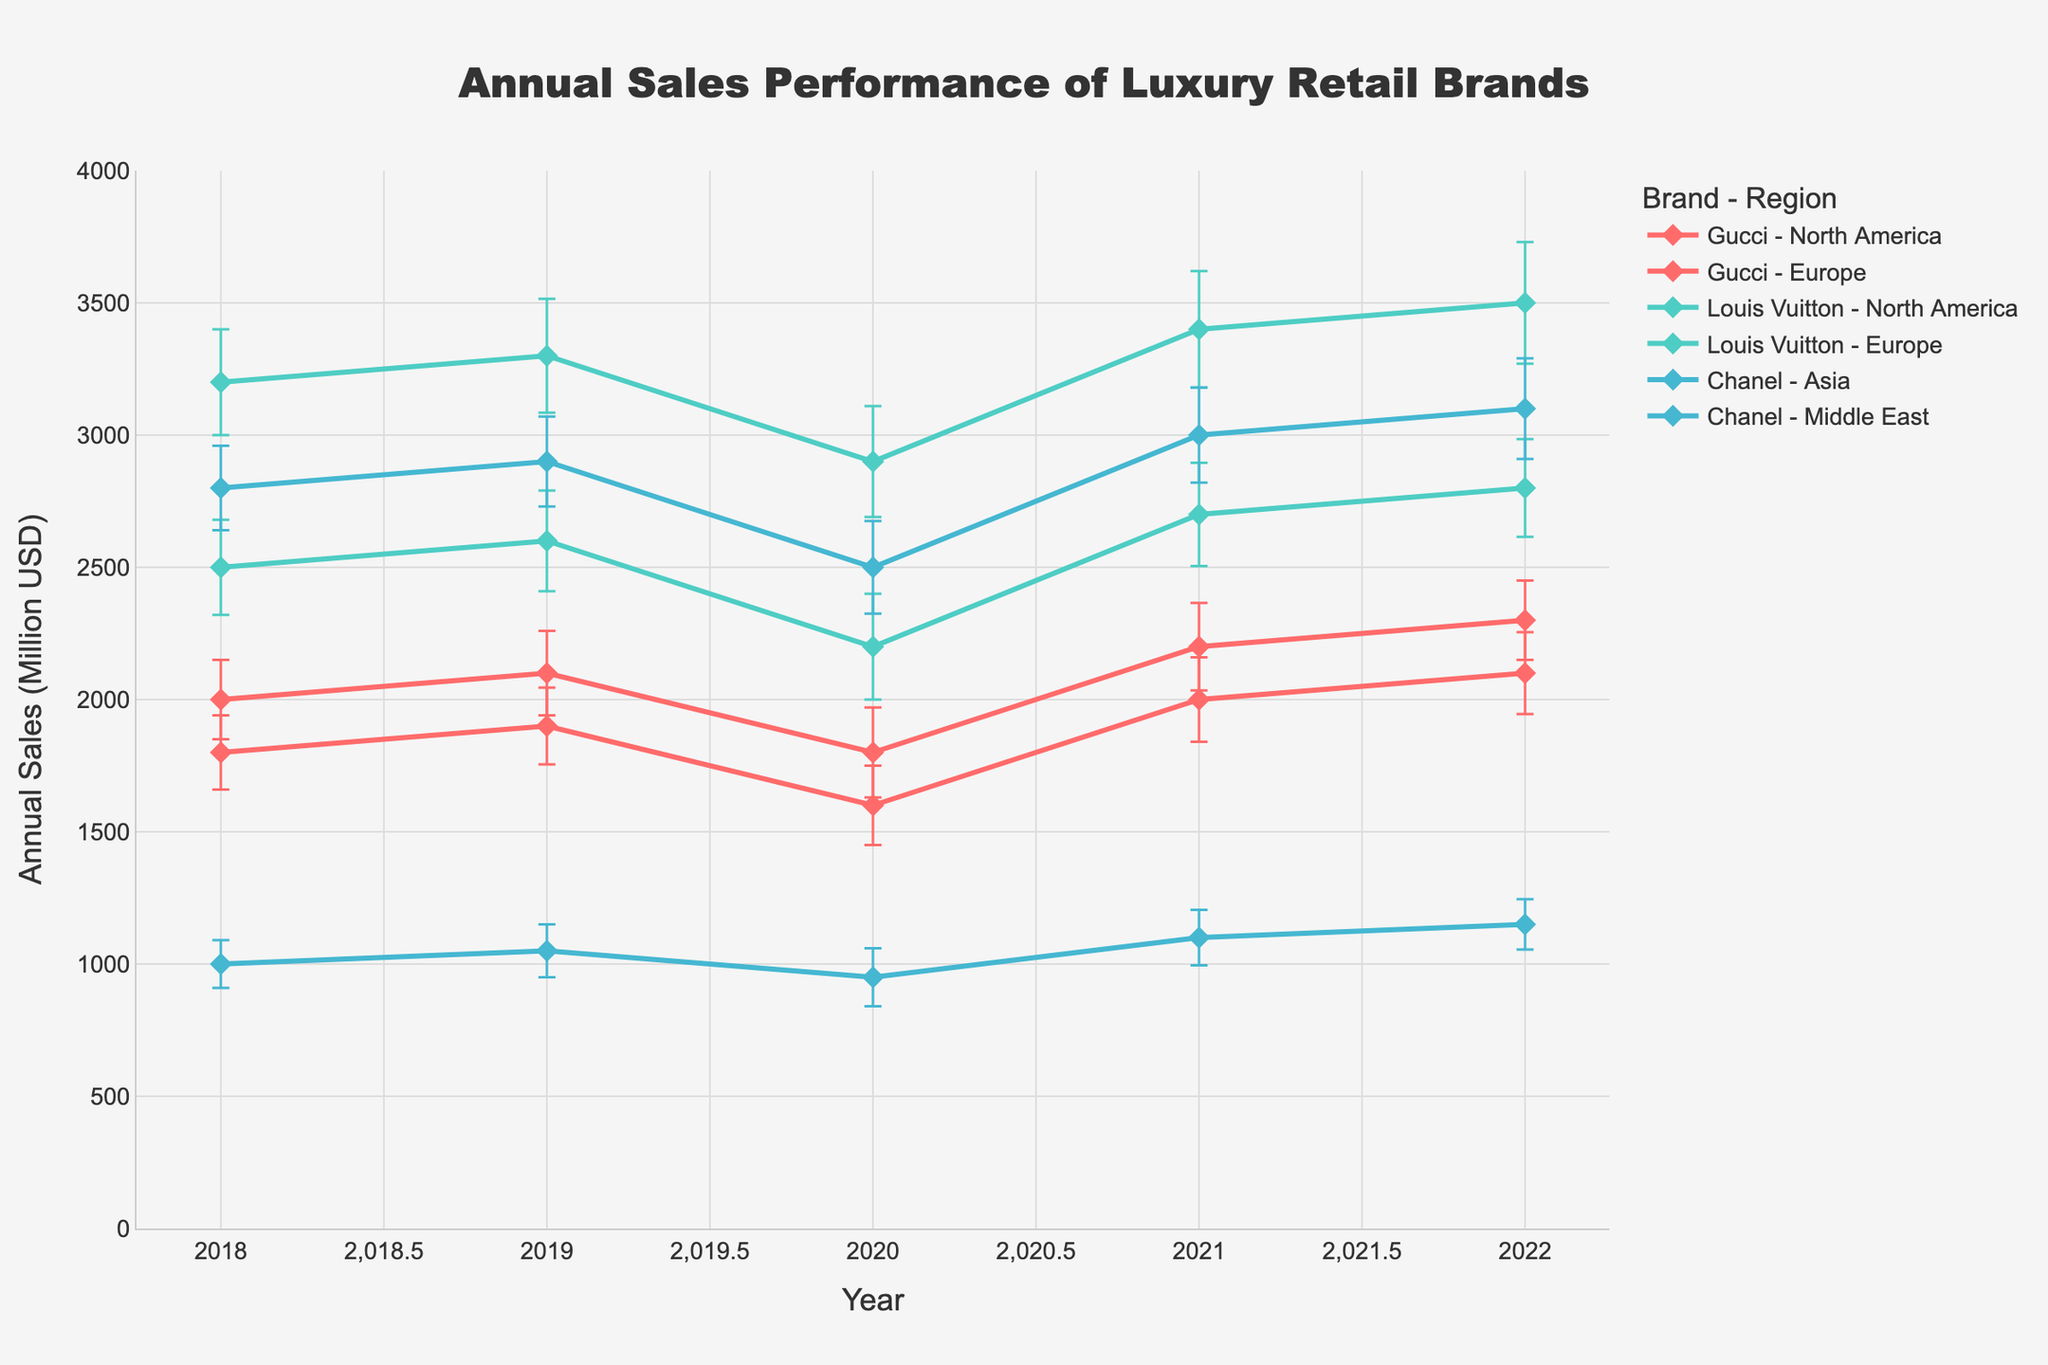What is the title of the plot? The title of the plot is usually located at the top center, formatted in a larger font for visibility. "Annual Sales Performance of Luxury Retail Brands" is displayed in this manner.
Answer: Annual Sales Performance of Luxury Retail Brands Which brand and region combination had the highest sales in 2022? To find this, we look at the year 2022 across all lines and identify the point with the highest y-value. The highest sales in 2022 appear for Louis Vuitton in North America.
Answer: Louis Vuitton - North America How did Chanel's sales performance in the Middle East change from 2018 to 2022? We need to locate Chanel in the Middle East and compare the sales in 2018 and 2022. The annual sales in the Middle East for Chanel increased from 1000 million USD in 2018 to 1150 million USD in 2022, indicating an upward trend.
Answer: Increased Which brand had the most significant year-over-year increase in sales from 2020 to 2021 in Europe? Check the lines for each brand in Europe and observe the vertical rise from 2020 to 2021. For Gucci, it increased from 1600 million USD to 2000 million USD. For Louis Vuitton, it increased from 2200 million USD to 2700 million USD. Louis Vuitton experienced the largest increase.
Answer: Louis Vuitton What was the effect of the standard deviation for Gucci in North America in 2020? Locate the error bars for Gucci in North America for the year 2020. The standard deviation of 170 million USD indicates the variability of sales data around the mean value of 1800 million USD, suggesting moderate uncertainty.
Answer: 170 million USD Comparing the standard deviation, which brand shows more consistent sales in Europe over the years shown on the plot? Consistency in sales can be inferred from smaller error bars. By comparing the error bars for Louis Vuitton and Gucci in Europe, Louis Vuitton's standard deviations range between 180 to 200 million USD, while Gucci's range between 140 to 160 million USD, making Gucci more consistent.
Answer: Gucci What was the overall trend for annual sales for Louis Vuitton in North America from 2018 to 2022? Look at the line for Louis Vuitton in North America from 2018 to 2022. The trend shows an initial increase, a dip in 2020, followed by a steady rise reaching a peak of 3500 million USD in 2022.
Answer: Upward trend with a dip in 2020 Which region recorded lower sales for Chanel in 2020, Asia or the Middle East? Locate Chanel's sales in both Asia and the Middle East for the year 2020. Chanel had sales of 2500 million USD in Asia and 950 million USD in the Middle East. Thus, the Middle East recorded lower sales.
Answer: Middle East How did sales for Gucci in Europe differ when comparing 2019 and 2021? Compare the sales values for Gucci in Europe in the years 2019 and 2021. The annual sales increased from 1900 million USD in 2019 to 2000 million USD in 2021.
Answer: Increased by 100 million USD Is there a noticeable difference in the sales trend for Gucci between North America and Europe from 2018 to 2022? Compare the lines for Gucci in both regions. North America shows a more fluctuating trend with a dip in 2020, while Europe exhibits a relatively steady but increasing trend.
Answer: Yes, fluctuating in North America and steady in Europe 